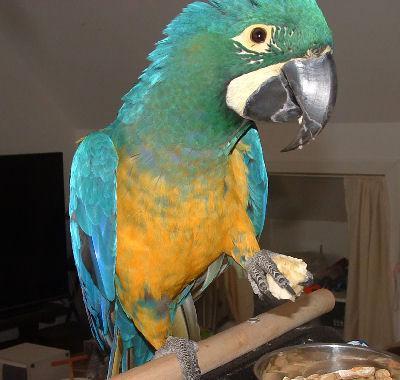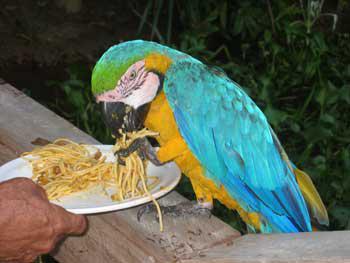The first image is the image on the left, the second image is the image on the right. Analyze the images presented: Is the assertion "An image contains one red-headed parrot facing rightward, and the other image contains blue-headed birds." valid? Answer yes or no. No. The first image is the image on the left, the second image is the image on the right. For the images displayed, is the sentence "There are at least two blue parrots in the right image." factually correct? Answer yes or no. No. 